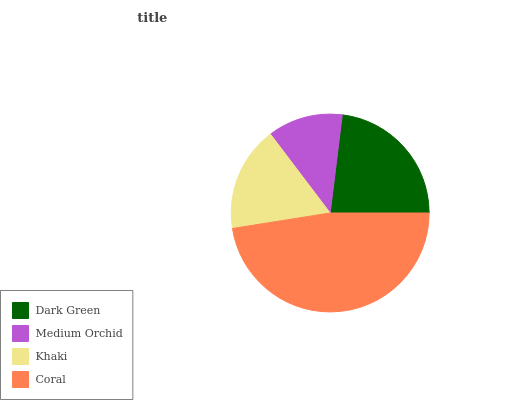Is Medium Orchid the minimum?
Answer yes or no. Yes. Is Coral the maximum?
Answer yes or no. Yes. Is Khaki the minimum?
Answer yes or no. No. Is Khaki the maximum?
Answer yes or no. No. Is Khaki greater than Medium Orchid?
Answer yes or no. Yes. Is Medium Orchid less than Khaki?
Answer yes or no. Yes. Is Medium Orchid greater than Khaki?
Answer yes or no. No. Is Khaki less than Medium Orchid?
Answer yes or no. No. Is Dark Green the high median?
Answer yes or no. Yes. Is Khaki the low median?
Answer yes or no. Yes. Is Coral the high median?
Answer yes or no. No. Is Dark Green the low median?
Answer yes or no. No. 